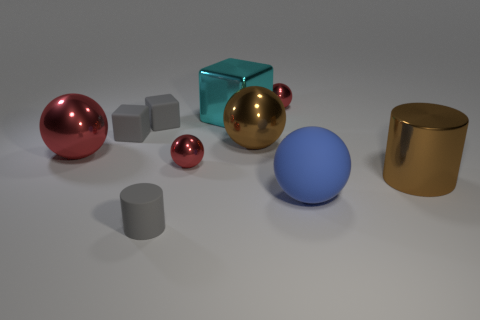Do the red metal thing that is right of the brown sphere and the brown sphere have the same size?
Provide a succinct answer. No. How many things are either tiny rubber cylinders left of the cyan shiny block or red metal blocks?
Your answer should be very brief. 1. Is there a red object of the same size as the blue matte thing?
Your answer should be very brief. Yes. There is a blue ball that is the same size as the brown ball; what is it made of?
Give a very brief answer. Rubber. What is the shape of the metallic object that is in front of the large red ball and right of the big metallic block?
Give a very brief answer. Cylinder. What is the color of the rubber sphere that is on the right side of the large red ball?
Make the answer very short. Blue. How big is the object that is in front of the big brown cylinder and right of the small matte cylinder?
Ensure brevity in your answer.  Large. Is the material of the blue ball the same as the red ball to the left of the small rubber cylinder?
Your answer should be compact. No. How many other red shiny objects have the same shape as the big red metallic thing?
Provide a short and direct response. 2. There is a big ball that is the same color as the big cylinder; what material is it?
Your answer should be compact. Metal. 